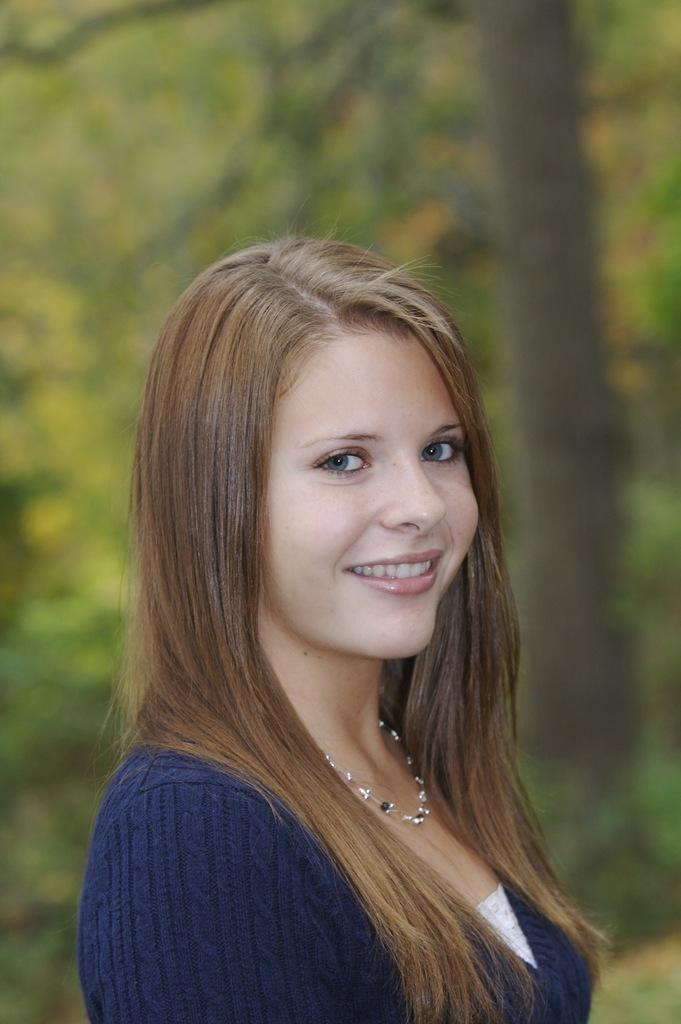Who is the main subject in the image? There is a lady in the center of the image. What is the lady doing in the image? The lady is smiling. What is the lady wearing in the image? The lady is wearing a dress. What can be seen in the background of the image? There are trees in the background of the image. What type of chain is hanging from the lady's neck in the image? There is no chain visible around the lady's neck in the image. 